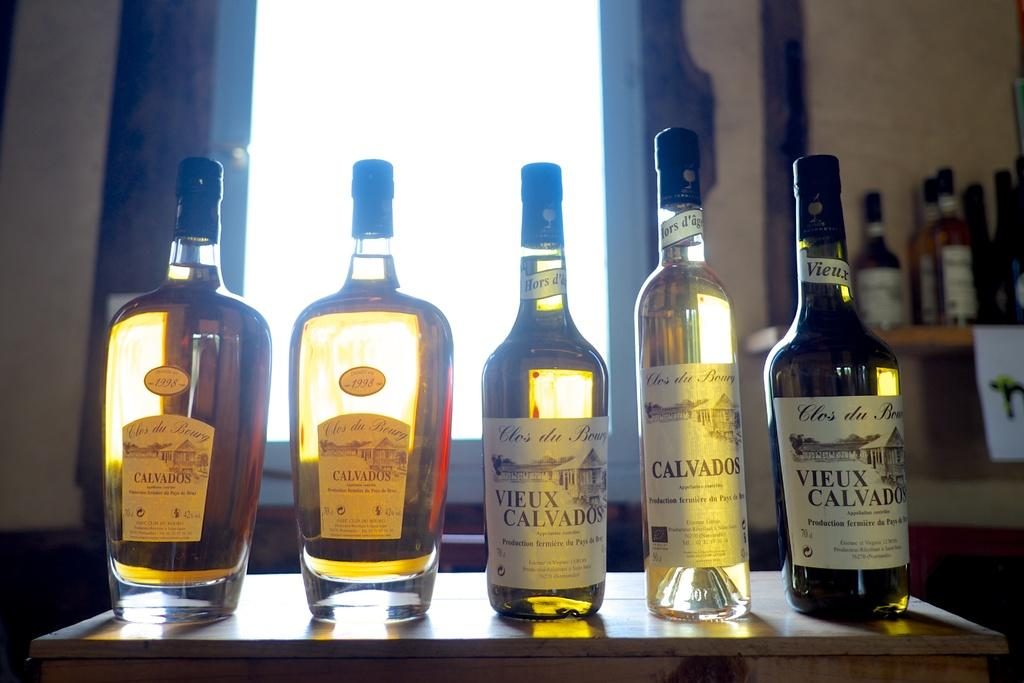<image>
Present a compact description of the photo's key features. five assorted bottles of Calvados sit on a table in front of a window. 